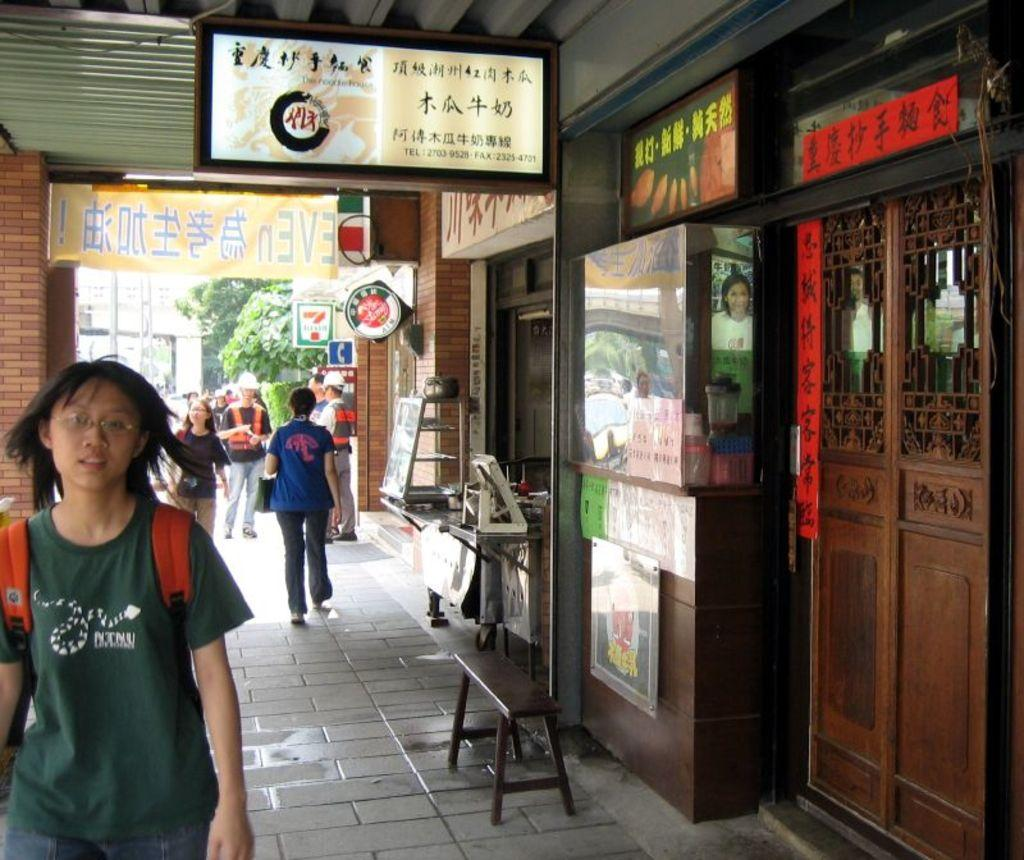What type of establishments can be seen on the right side of the image? There are stores on the right side of the image. What is happening in the middle of the image? There are people walking in the middle of the image. What are the people carrying on their backs? The people are wearing backpacks. What type of vegetation is present in the middle of the image? There are trees in the middle of the image. Can you see a man swinging on a swing in the image? There is no swing or man swinging on a swing present in the image. What type of flight is visible in the image? There is no flight present in the image. 